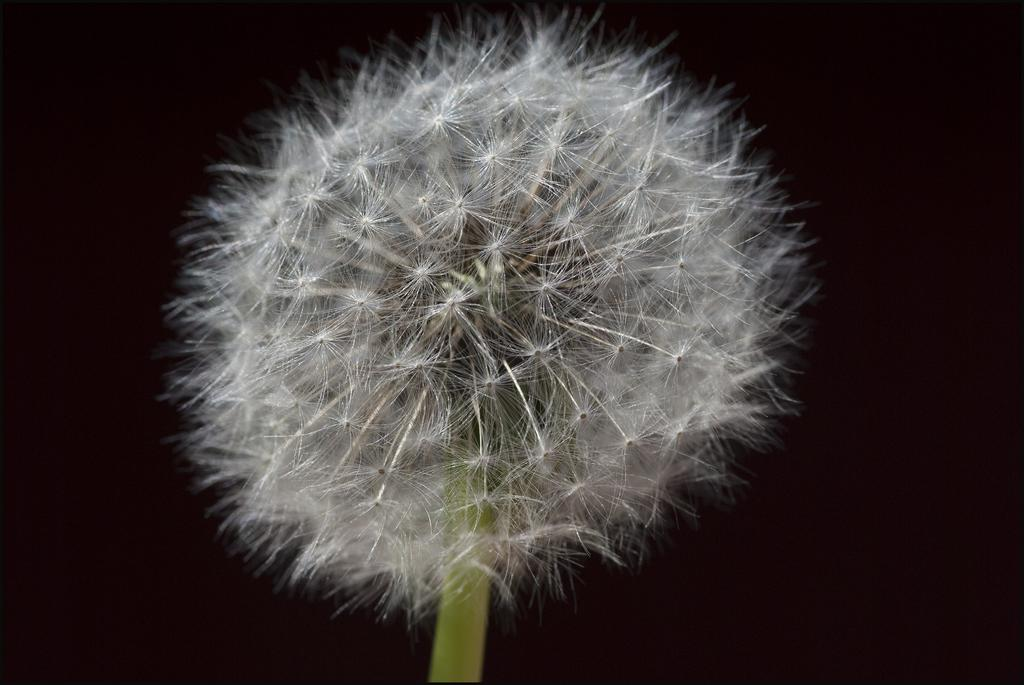What is the main subject of the image? There is a flower in the image. What part of the flower is visible in the image? There is a stem in the image. What can be observed about the background of the image? The background of the image is dark. Can you see any cobwebs on the flower in the image? There is no mention of cobwebs in the image, so it cannot be determined if any are present. What type of peace is depicted in the image? The image does not depict any concept of peace; it features a flower and its stem. 